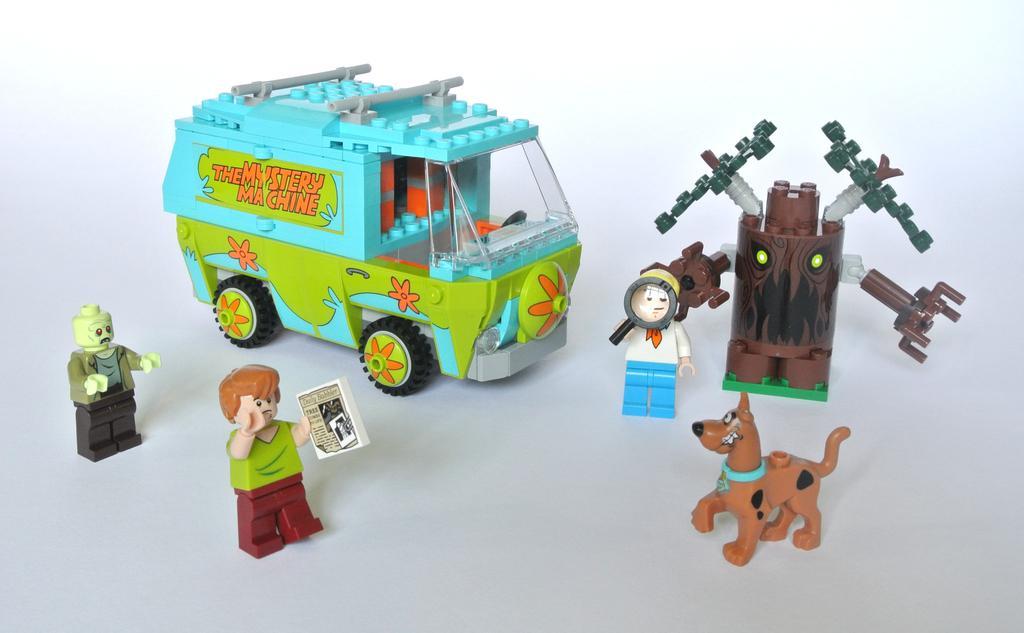Describe this image in one or two sentences. In this image I can see toys of 3 people, a dog, robotic tree and a vehicle. There is a white background. 